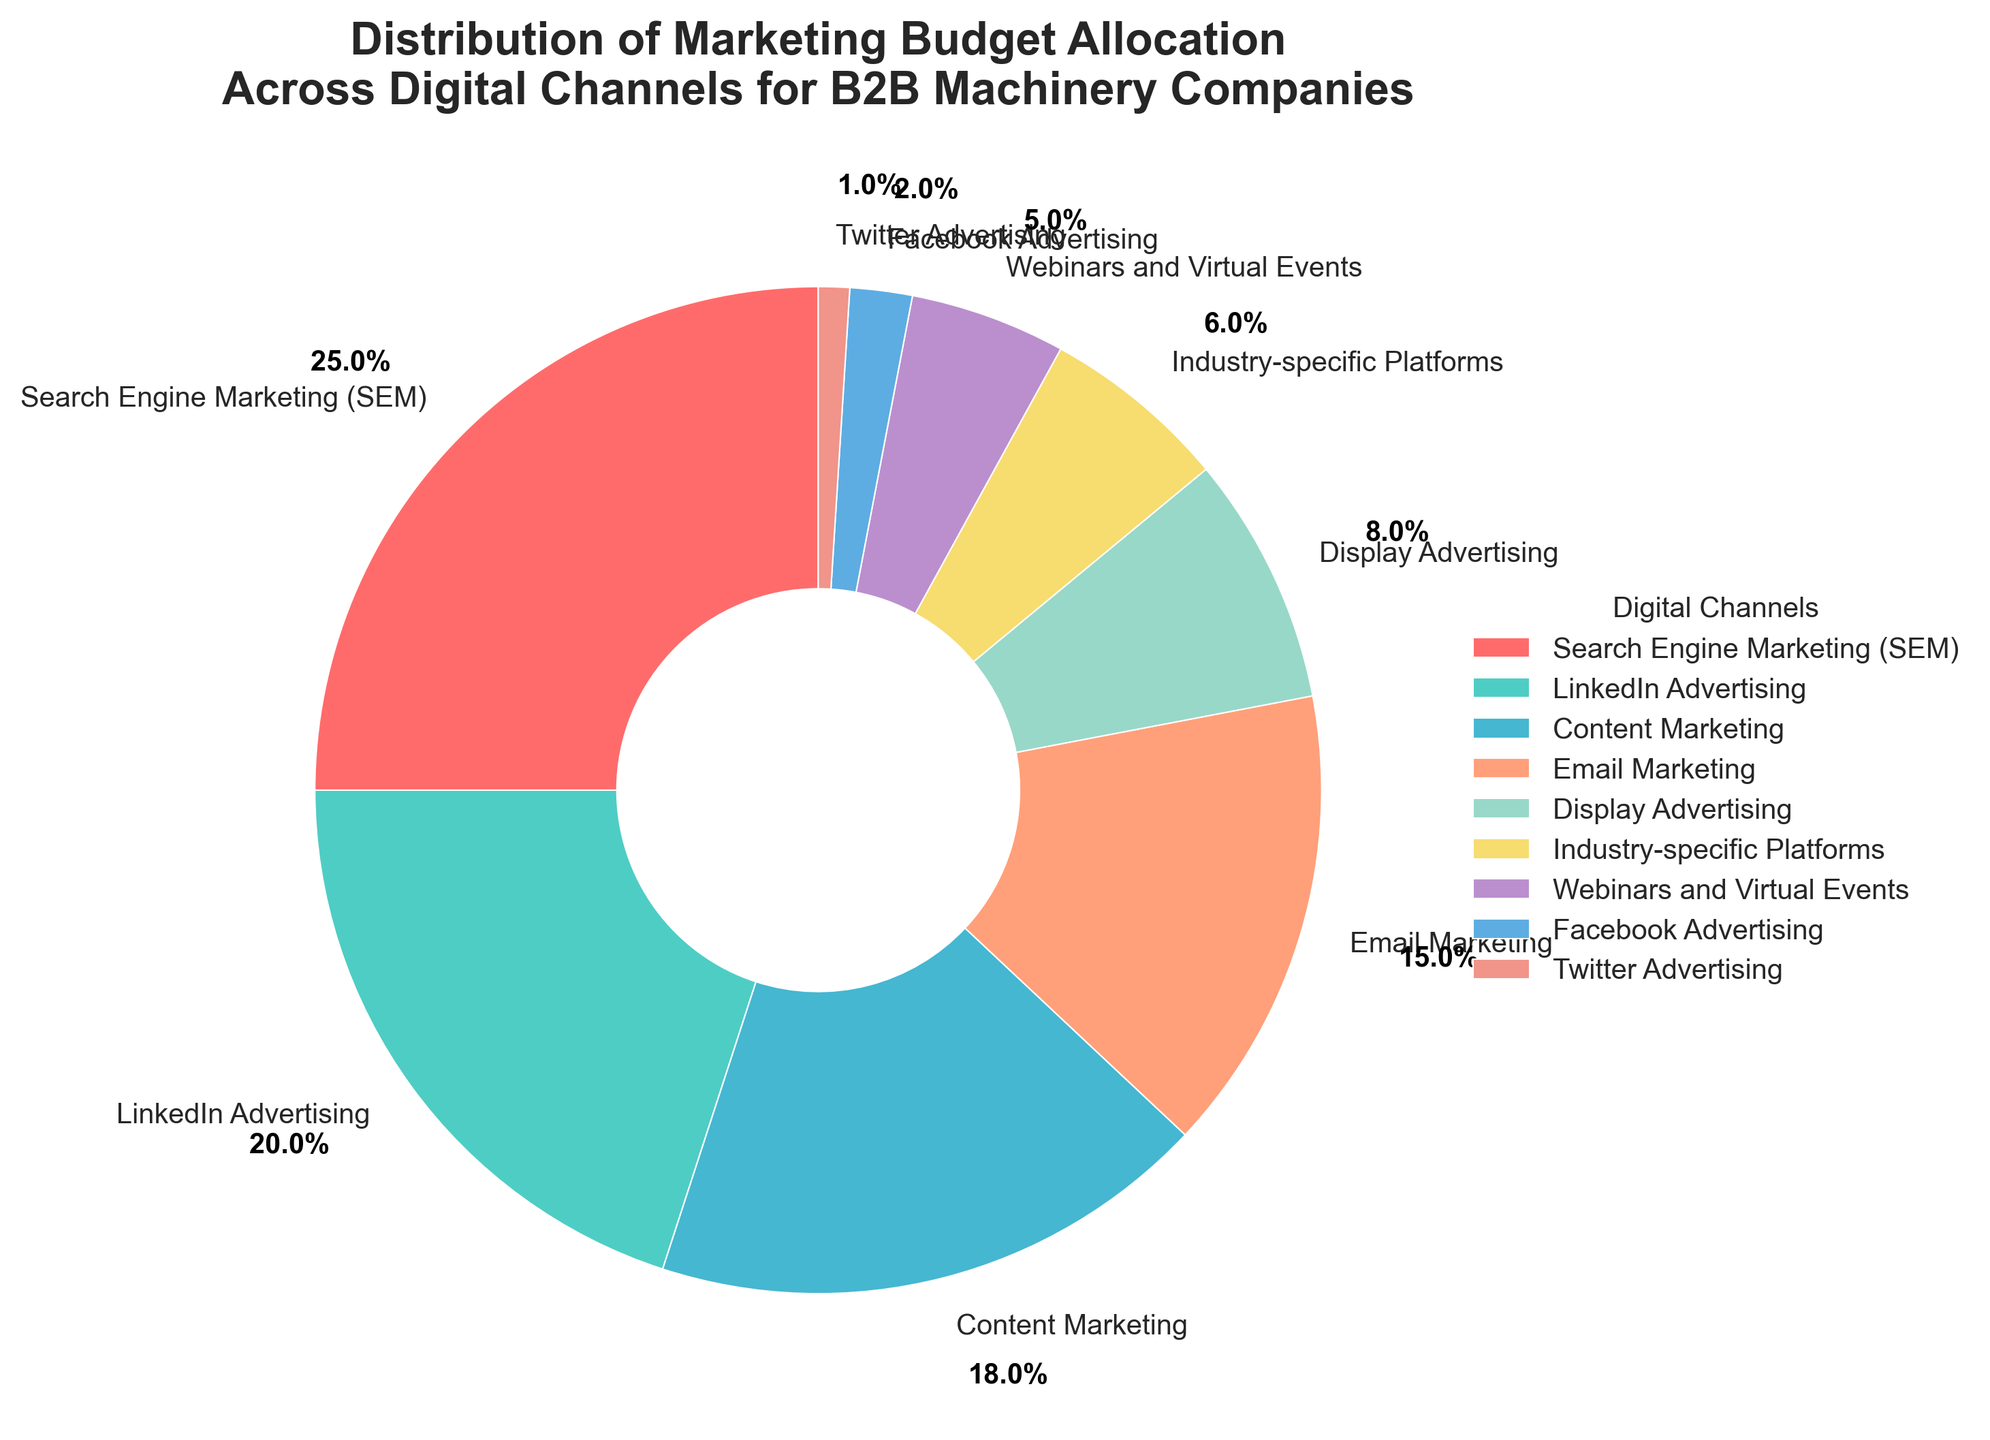What percentage of the marketing budget is allocated to LinkedIn Advertising and Email Marketing combined? To find the combined percentage, add the individual percentages for LinkedIn Advertising and Email Marketing. LinkedIn Advertising is 20% and Email Marketing is 15%. The sum is 20% + 15% = 35%.
Answer: 35% Is the percentage of the budget allocated to Search Engine Marketing (SEM) greater than the total percentage allocated to Display Advertising, Industry-specific Platforms, and Webinars and Virtual Events together? First, add the percentages for Display Advertising (8%), Industry-specific Platforms (6%), and Webinars and Virtual Events (5%). The total is 8% + 6% + 5% = 19%. Then, compare this total with the percentage for SEM, which is 25%. Since 25% is greater than 19%, the answer is yes.
Answer: Yes Which channel has the third-highest percentage of the marketing budget allocation, and what is that percentage? Looking at the chart, the channels in descending order of percentage are: 1) SEM (25%), 2) LinkedIn Advertising (20%), 3) Content Marketing (18%). So, the third-highest percentage is for Content Marketing and it is 18%.
Answer: Content Marketing, 18% Is the budget allocation for Content Marketing higher than the combined allocation for Facebook Advertising and Twitter Advertising? The percentage for Content Marketing is 18%. The combined percentage for Facebook Advertising (2%) and Twitter Advertising (1%) is 2% + 1% = 3%. Since 18% is greater than 3%, the answer is yes.
Answer: Yes How much greater is the budget allocation for Search Engine Marketing (SEM) than for Display Advertising? Subtract the percentage for Display Advertising (8%) from the percentage for SEM (25%). The difference is 25% - 8% = 17%.
Answer: 17% Which channel represents the smallest portion of the marketing budget, and what is that percentage? According to the chart, Twitter Advertising has the smallest portion of the marketing budget with a percentage of 1%.
Answer: Twitter Advertising, 1% Combine the percentage allocations for LinkedIn Advertising, Content Marketing, and Email Marketing, and determine if it exceeds 50%. First, sum the percentages: LinkedIn Advertising (20%), Content Marketing (18%), and Email Marketing (15%) gives us 20% + 18% + 15% = 53%. Since 53% is greater than 50%, the answer is yes.
Answer: Yes Compare the budget allocations for Industry-specific Platforms and Webinars and Virtual Events. Which one has a higher budget allocation, and by how much? The percentage for Industry-specific Platforms is 6%, and for Webinars and Virtual Events, it is 5%. Subtract 5% from 6% to get the difference, which is 1%. Industry-specific Platforms has a higher allocation by 1%.
Answer: Industry-specific Platforms, 1% 